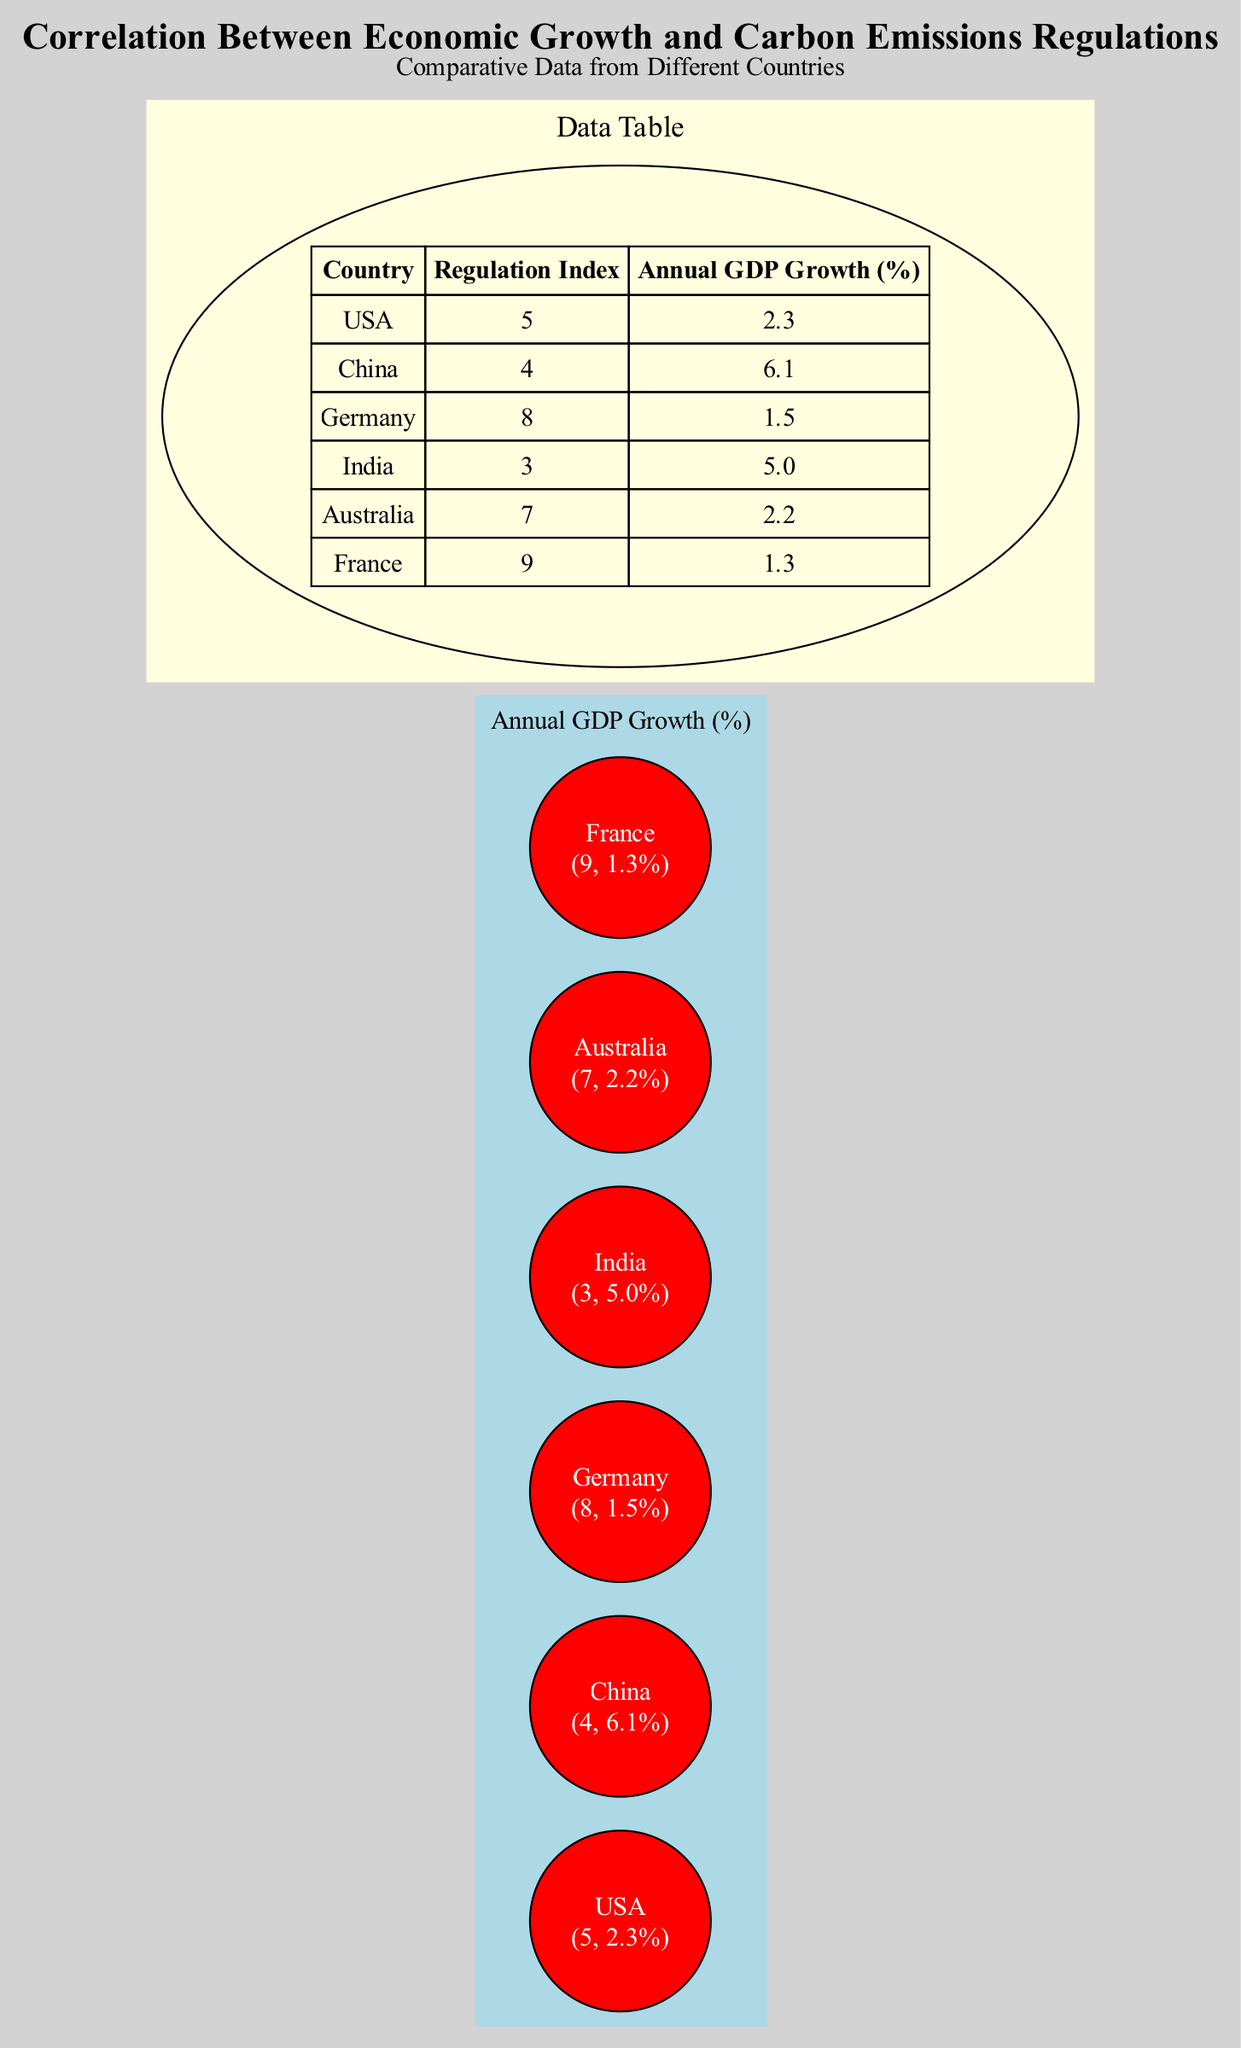What is the regulation index for Germany? The regulation index for Germany is indicated in the data table under the "Regulation Index" column, and it shows a value of 8 for Germany.
Answer: 8 Which country has the highest annual GDP growth? By checking the "Annual GDP Growth (%)" data, China shows the highest value of 6.1%, making it the country with the top GDP growth in the provided data.
Answer: China How many countries have a regulation index of 5 or higher? Analyzing the "Regulation Index" values, we list the countries: USA (5), Germany (8), Australia (7), and France (9). This gives us a total of four countries.
Answer: 4 What is the relationship between carbon emissions regulations and GDP growth based on this diagram? Observing the scatter plot, we note that countries with higher regulation indices do not necessarily have correspondingly higher GDP growth rates, indicating a weak correlation between the two parameters.
Answer: Weak correlation Which country has the lowest annual GDP growth? By looking at the "Annual GDP Growth (%)" data, France has the lowest growth rate among the countries listed at 1.3%.
Answer: France What is the regulation index for Australia compared to India? The data indicates that Australia has a regulation index of 7, while India has a lower regulation index of 3 when we compare their respective values in the "Regulation Index" column.
Answer: 7 vs 3 Is there a country with a high regulation index and low GDP growth? By reviewing the scatter plot, we find that France has a high regulation index of 9 but a low GDP growth of 1.3%, showcasing this scenario.
Answer: Yes Which country has an annual GDP growth of 2.2%? The table lists Australia’s annual GDP growth as 2.2%, clearly identifying it as the country with this specific growth rate.
Answer: Australia 